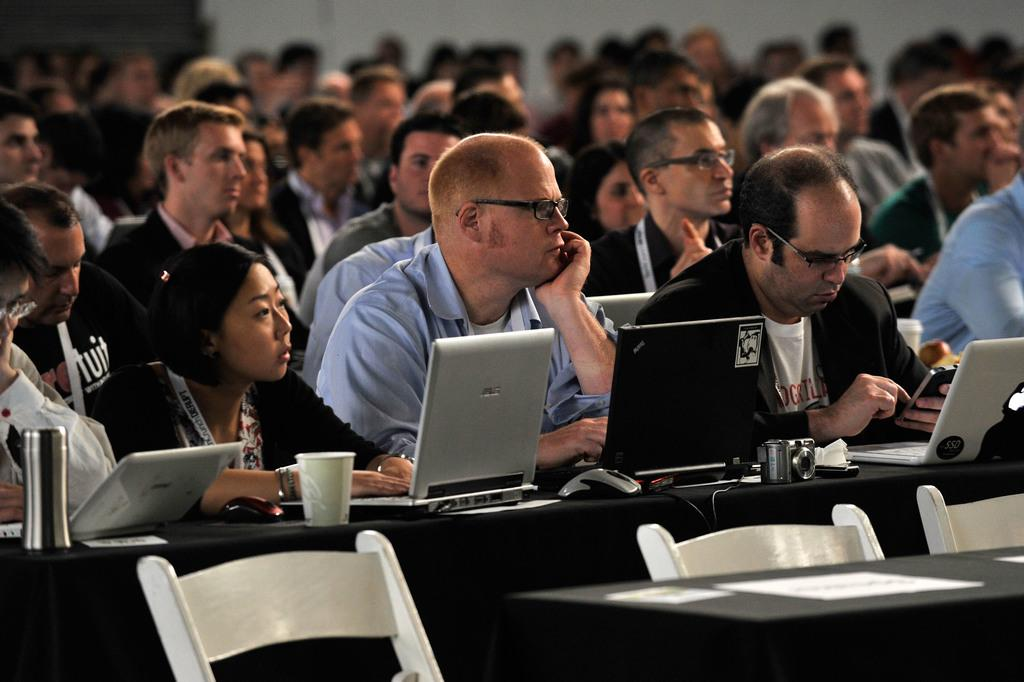What are the people in the image doing? The people in the image are sitting on chairs. What is present on the table in the image? There is a table in the image, and on it, there are laptops, cups, and a camera. How many laptops are visible on the table? There are laptops on the table, but the exact number is not specified in the facts. What might the people be using the laptops for? The people might be using the laptops for work, communication, or entertainment. What type of stone is being used as a flagpole in the image? There is no stone or flagpole present in the image; it features people sitting on chairs with a table and various objects on it. 